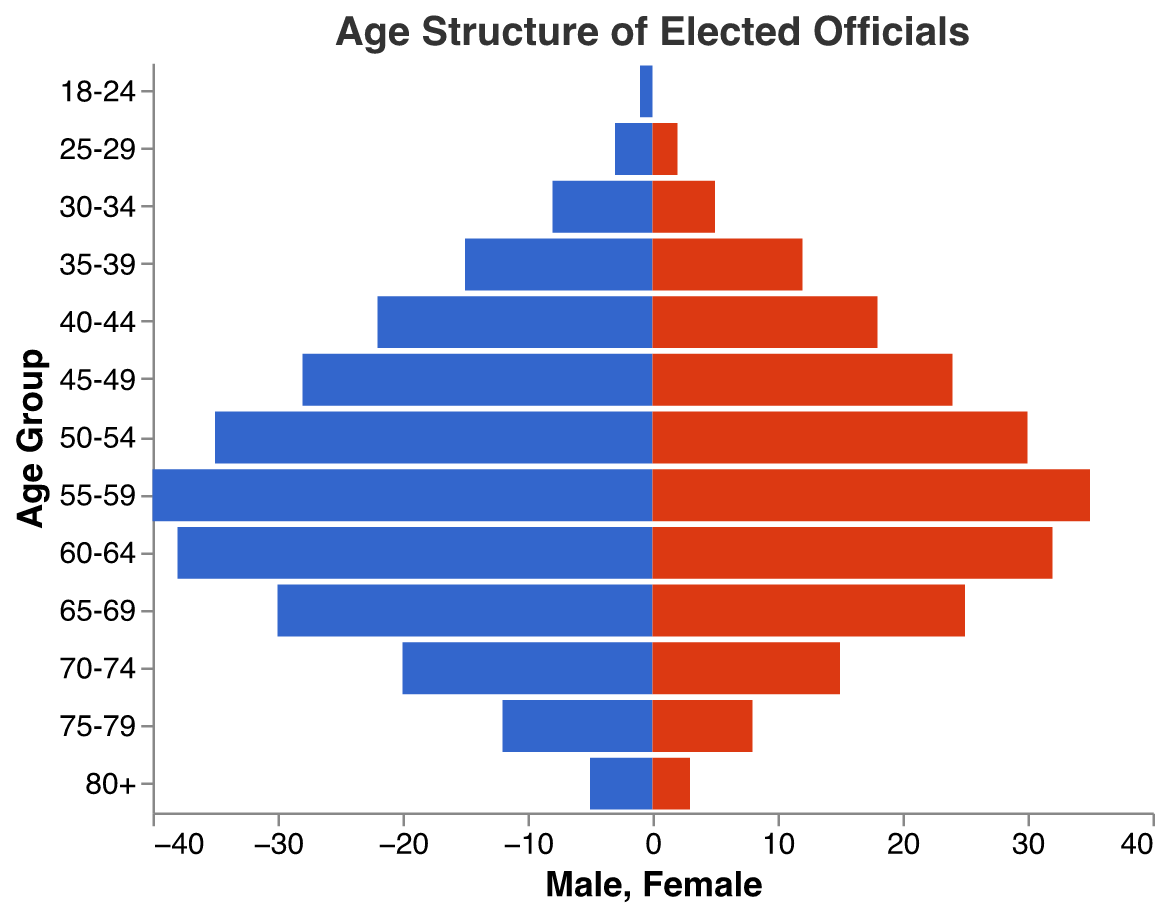What's the age range with the highest number of male officials? The age range with the highest number of male officials is where the bar extends furthest to the left since Male values are negative. The age group is 55-59 with 40 male officials.
Answer: 55-59 What's the total number of female officials in the 50-54 age range? In the 50-54 age range, the bar for females extends to 30 on the x-axis, indicating there are 30 female officials.
Answer: 30 Which gender has more officials in the 65-69 age range, and by how much? Comparing the length of the bars for males and females in the 65-69 age range, males have 30 officials, and females have 25. So, males have 5 more officials than females.
Answer: Males by 5 Which age group has the least number of female officials? The bar for females is shortest in the 18-24 age group, extending to 0, indicating there are no female officials in this age range.
Answer: 18-24 How does the number of male officials in the 30-34 age range compare to the number of female officials in the same range? The number of male officials (8) compared to female officials (5) in the 30-34 age range shows that there are 3 more male officials than female officials.
Answer: 3 more males What is the combined total number of officials (males + females) in the 40-44 age range? The number of male officials in this range is 22, and the number of female officials is 18. Adding them gives a total of 40 officials in the 40-44 age range.
Answer: 40 In which age group is the difference between the number of male and female officials the greatest? The difference is calculated for each age group. The 55-59 age range has 40 males and 35 females, giving a difference of 5. Checking other age groups, no group has a larger difference.
Answer: 55-59 What's the total number of male and female officials aged 75+? Summing the number of male (12 for 75-79, 5 for 80+) and female officials (8 for 75-79, 3 for 80+) gives us: 12 + 5 + 8 + 3 = 28 officials aged 75+.
Answer: 28 What age group has equal numbers of male and female officials, if any? Checking each age group for equality, none of the age groups have exactly equal numbers of male and female officials.
Answer: None 